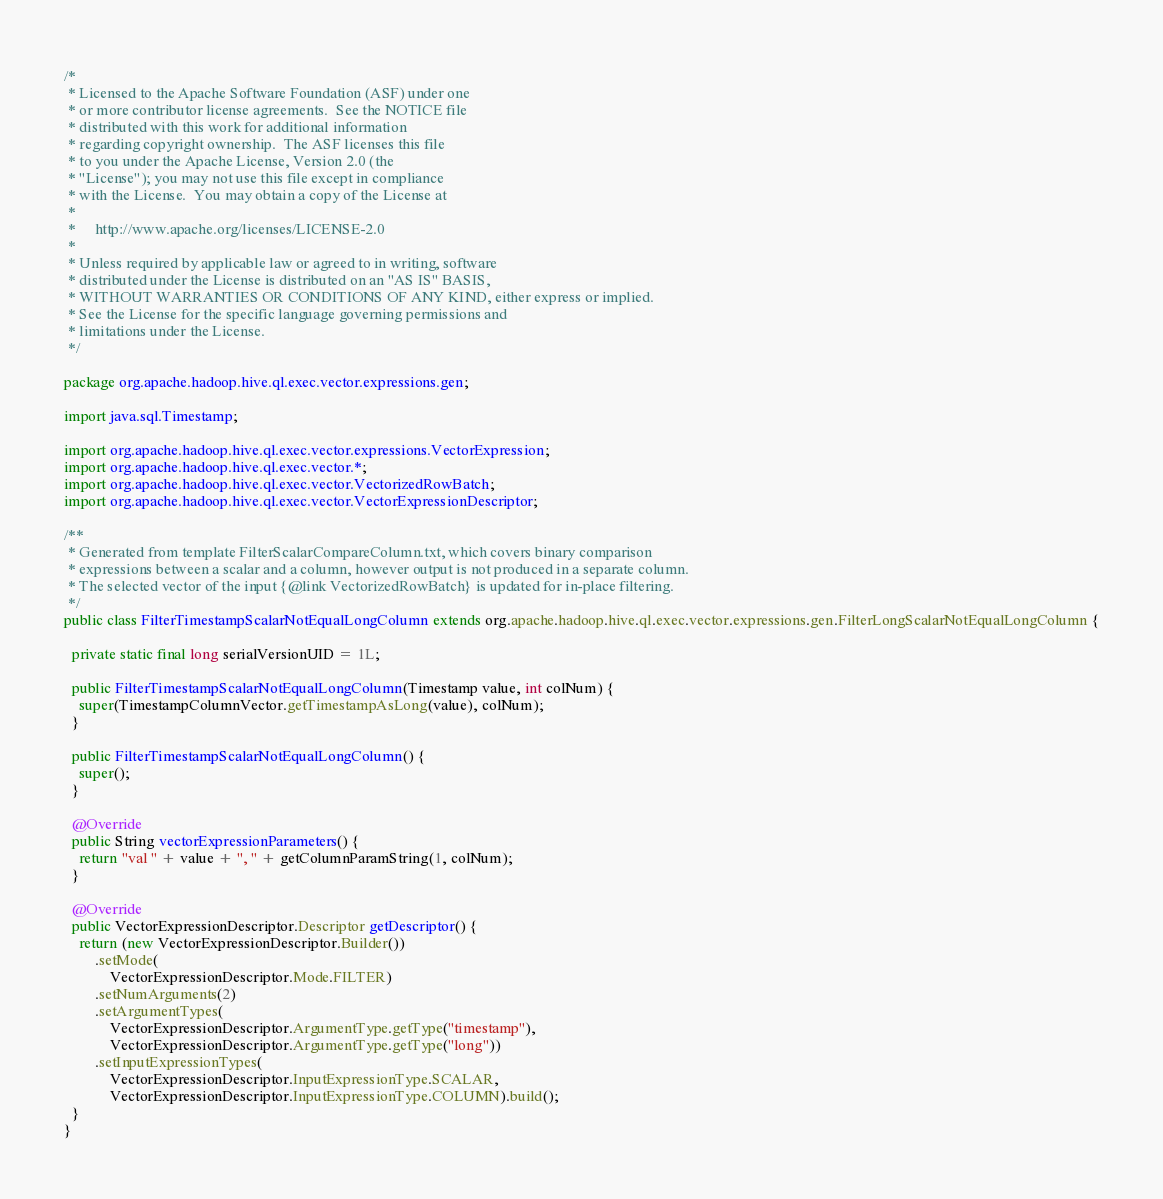<code> <loc_0><loc_0><loc_500><loc_500><_Java_>/*
 * Licensed to the Apache Software Foundation (ASF) under one
 * or more contributor license agreements.  See the NOTICE file
 * distributed with this work for additional information
 * regarding copyright ownership.  The ASF licenses this file
 * to you under the Apache License, Version 2.0 (the
 * "License"); you may not use this file except in compliance
 * with the License.  You may obtain a copy of the License at
 *
 *     http://www.apache.org/licenses/LICENSE-2.0
 *
 * Unless required by applicable law or agreed to in writing, software
 * distributed under the License is distributed on an "AS IS" BASIS,
 * WITHOUT WARRANTIES OR CONDITIONS OF ANY KIND, either express or implied.
 * See the License for the specific language governing permissions and
 * limitations under the License.
 */

package org.apache.hadoop.hive.ql.exec.vector.expressions.gen;

import java.sql.Timestamp;

import org.apache.hadoop.hive.ql.exec.vector.expressions.VectorExpression;
import org.apache.hadoop.hive.ql.exec.vector.*;
import org.apache.hadoop.hive.ql.exec.vector.VectorizedRowBatch;
import org.apache.hadoop.hive.ql.exec.vector.VectorExpressionDescriptor;

/**
 * Generated from template FilterScalarCompareColumn.txt, which covers binary comparison
 * expressions between a scalar and a column, however output is not produced in a separate column.
 * The selected vector of the input {@link VectorizedRowBatch} is updated for in-place filtering.
 */
public class FilterTimestampScalarNotEqualLongColumn extends org.apache.hadoop.hive.ql.exec.vector.expressions.gen.FilterLongScalarNotEqualLongColumn {

  private static final long serialVersionUID = 1L;

  public FilterTimestampScalarNotEqualLongColumn(Timestamp value, int colNum) {
    super(TimestampColumnVector.getTimestampAsLong(value), colNum);
  }

  public FilterTimestampScalarNotEqualLongColumn() {
    super();
  }

  @Override
  public String vectorExpressionParameters() {
    return "val " + value + ", " + getColumnParamString(1, colNum);
  }

  @Override
  public VectorExpressionDescriptor.Descriptor getDescriptor() {
    return (new VectorExpressionDescriptor.Builder())
        .setMode(
            VectorExpressionDescriptor.Mode.FILTER)
        .setNumArguments(2)
        .setArgumentTypes(
            VectorExpressionDescriptor.ArgumentType.getType("timestamp"),
            VectorExpressionDescriptor.ArgumentType.getType("long"))
        .setInputExpressionTypes(
            VectorExpressionDescriptor.InputExpressionType.SCALAR,
            VectorExpressionDescriptor.InputExpressionType.COLUMN).build();
  }
}
</code> 